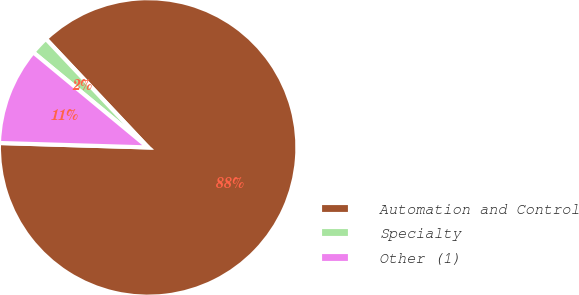<chart> <loc_0><loc_0><loc_500><loc_500><pie_chart><fcel>Automation and Control<fcel>Specialty<fcel>Other (1)<nl><fcel>87.5%<fcel>1.97%<fcel>10.53%<nl></chart> 